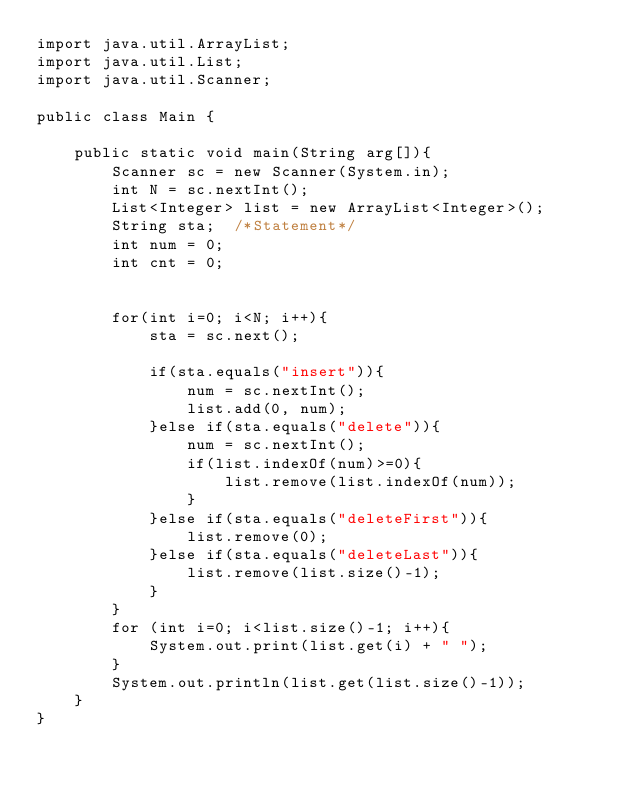<code> <loc_0><loc_0><loc_500><loc_500><_Java_>import java.util.ArrayList;
import java.util.List;
import java.util.Scanner;

public class Main {
	
	public static void main(String arg[]){
		Scanner sc = new Scanner(System.in);
		int N = sc.nextInt();
		List<Integer> list = new ArrayList<Integer>();
		String sta;  /*Statement*/
		int num = 0;
		int cnt = 0;

		
		for(int i=0; i<N; i++){
			sta = sc.next();
			
			if(sta.equals("insert")){
				num = sc.nextInt();
				list.add(0, num);
			}else if(sta.equals("delete")){
				num = sc.nextInt();
				if(list.indexOf(num)>=0){
					list.remove(list.indexOf(num));
				}
			}else if(sta.equals("deleteFirst")){
				list.remove(0);
			}else if(sta.equals("deleteLast")){
				list.remove(list.size()-1);
			}
		}
		for (int i=0; i<list.size()-1; i++){
	        System.out.print(list.get(i) + " ");
		}
		System.out.println(list.get(list.size()-1));
	}
}
</code> 